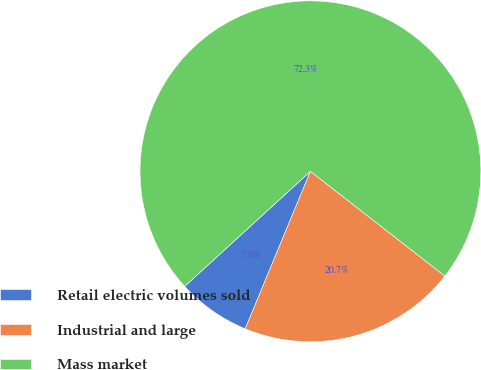Convert chart. <chart><loc_0><loc_0><loc_500><loc_500><pie_chart><fcel>Retail electric volumes sold<fcel>Industrial and large<fcel>Mass market<nl><fcel>6.96%<fcel>20.71%<fcel>72.33%<nl></chart> 